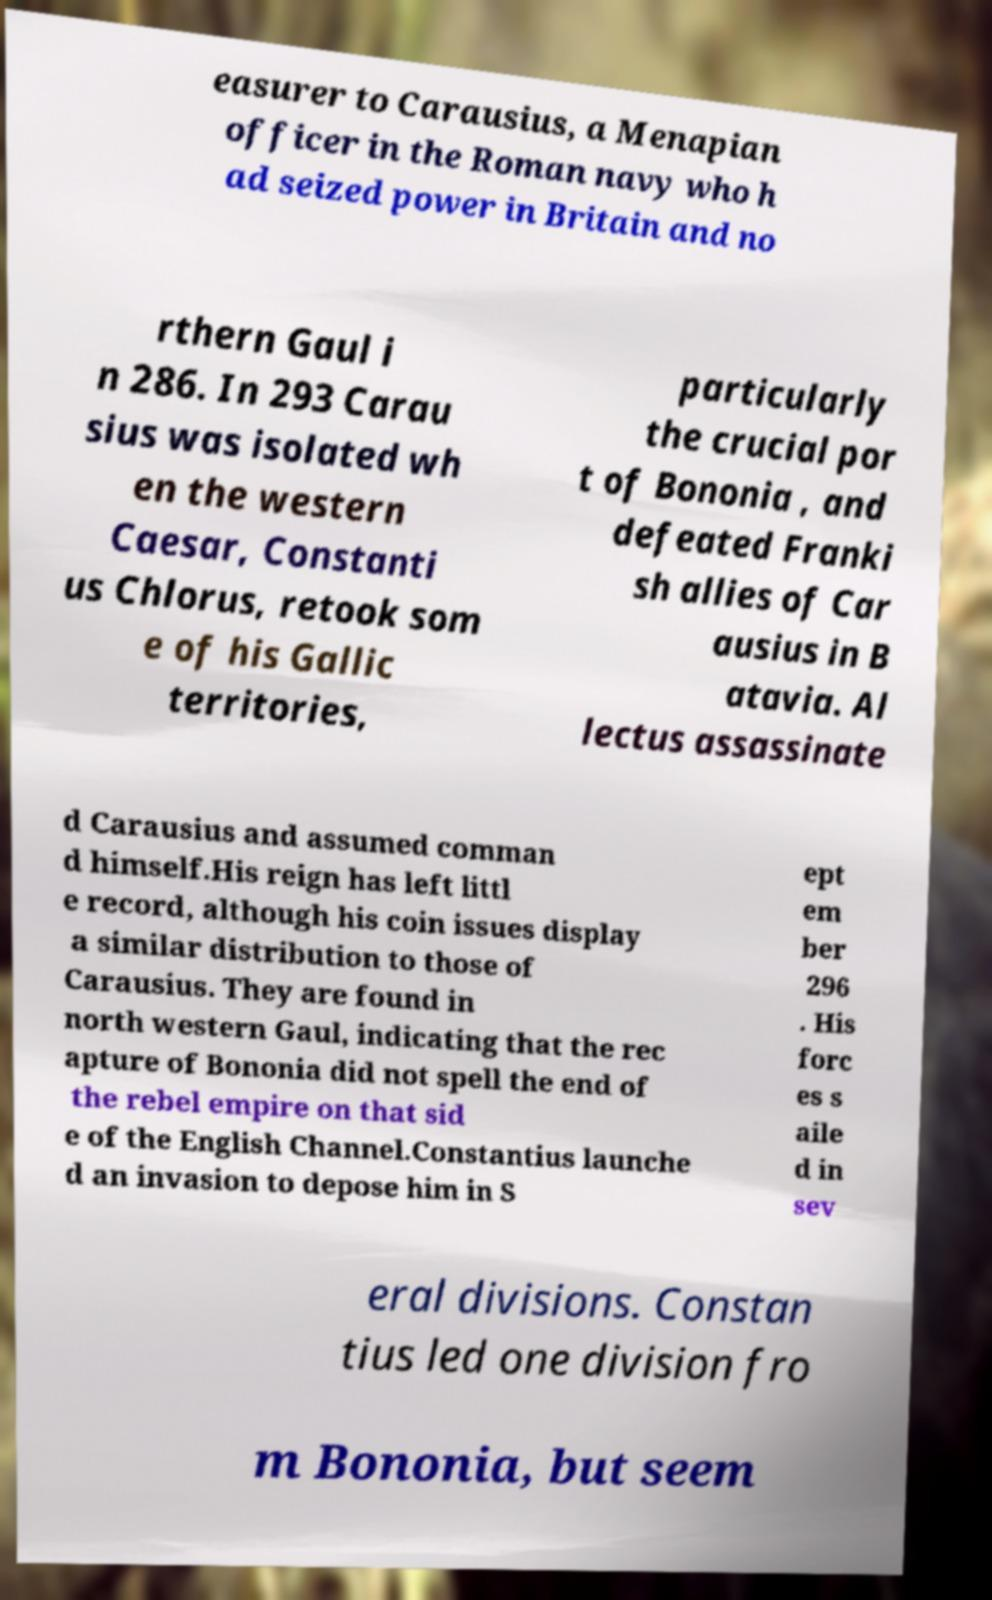Please identify and transcribe the text found in this image. easurer to Carausius, a Menapian officer in the Roman navy who h ad seized power in Britain and no rthern Gaul i n 286. In 293 Carau sius was isolated wh en the western Caesar, Constanti us Chlorus, retook som e of his Gallic territories, particularly the crucial por t of Bononia , and defeated Franki sh allies of Car ausius in B atavia. Al lectus assassinate d Carausius and assumed comman d himself.His reign has left littl e record, although his coin issues display a similar distribution to those of Carausius. They are found in north western Gaul, indicating that the rec apture of Bononia did not spell the end of the rebel empire on that sid e of the English Channel.Constantius launche d an invasion to depose him in S ept em ber 296 . His forc es s aile d in sev eral divisions. Constan tius led one division fro m Bononia, but seem 